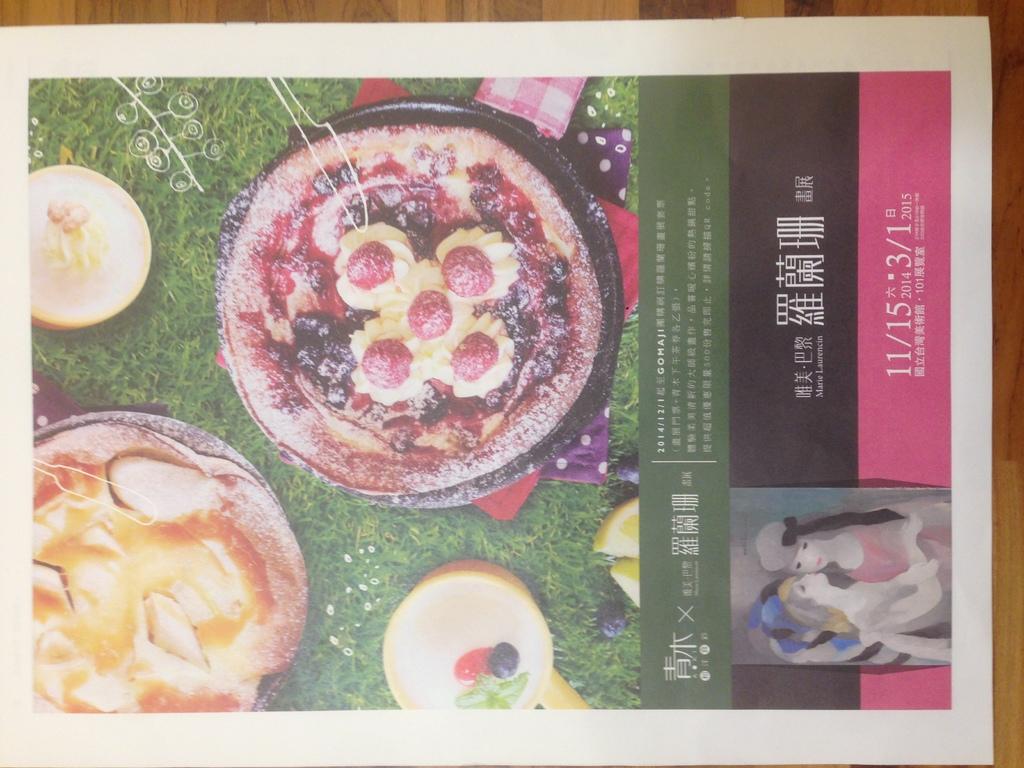What year is this poster from?
Your answer should be very brief. 2015. 